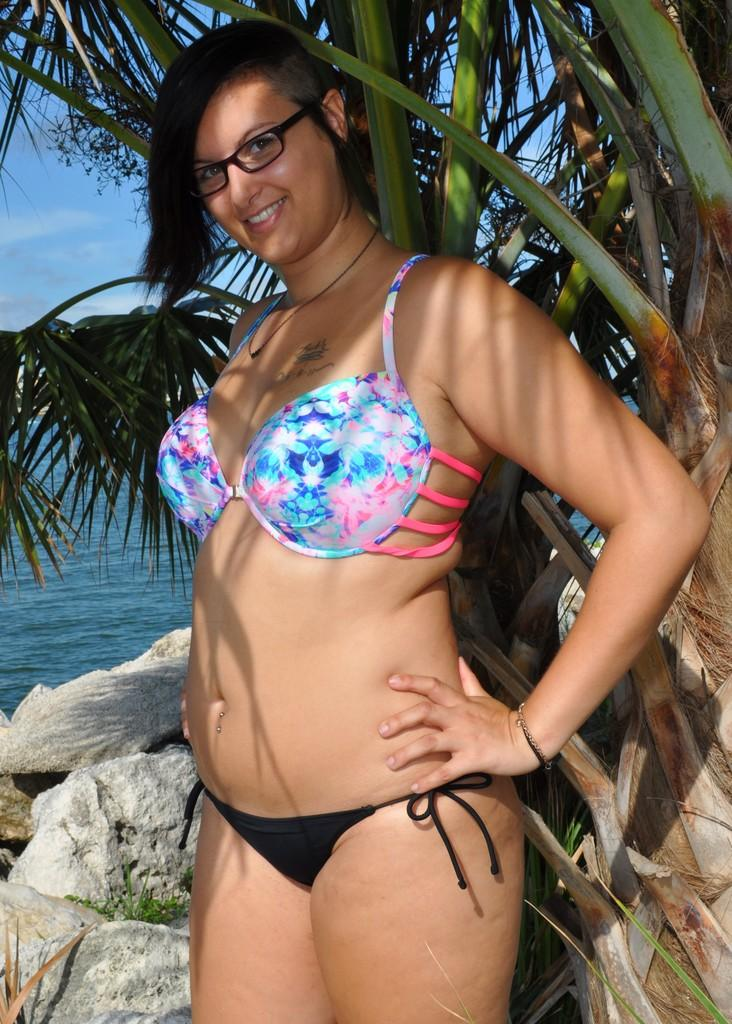Who is present in the image? There is a woman in the image. What is the woman doing in the image? The woman is smiling in the image. Where is the woman standing in the image? The woman is standing on the floor in the image. What can be seen in the background of the image? There is sky, a tree, and a lake visible in the background of the image. What time is displayed on the clock in the image? There is no clock present in the image. What type of rock is the woman holding in the image? There is no rock present in the image. 